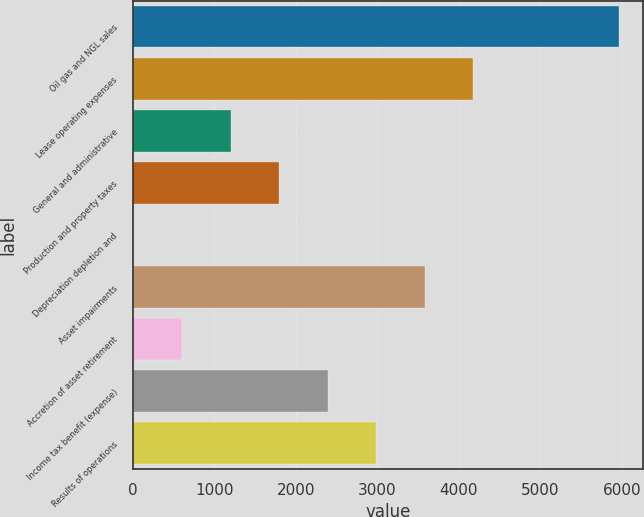Convert chart. <chart><loc_0><loc_0><loc_500><loc_500><bar_chart><fcel>Oil gas and NGL sales<fcel>Lease operating expenses<fcel>General and administrative<fcel>Production and property taxes<fcel>Depreciation depletion and<fcel>Asset impairments<fcel>Accretion of asset retirement<fcel>Income tax benefit (expense)<fcel>Results of operations<nl><fcel>5964<fcel>4177.4<fcel>1199.75<fcel>1795.28<fcel>8.69<fcel>3581.87<fcel>604.22<fcel>2390.81<fcel>2986.34<nl></chart> 